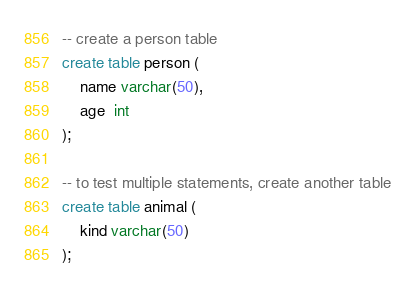Convert code to text. <code><loc_0><loc_0><loc_500><loc_500><_SQL_>-- create a person table
create table person (
    name varchar(50),
    age  int
);

-- to test multiple statements, create another table
create table animal (
    kind varchar(50)
);</code> 